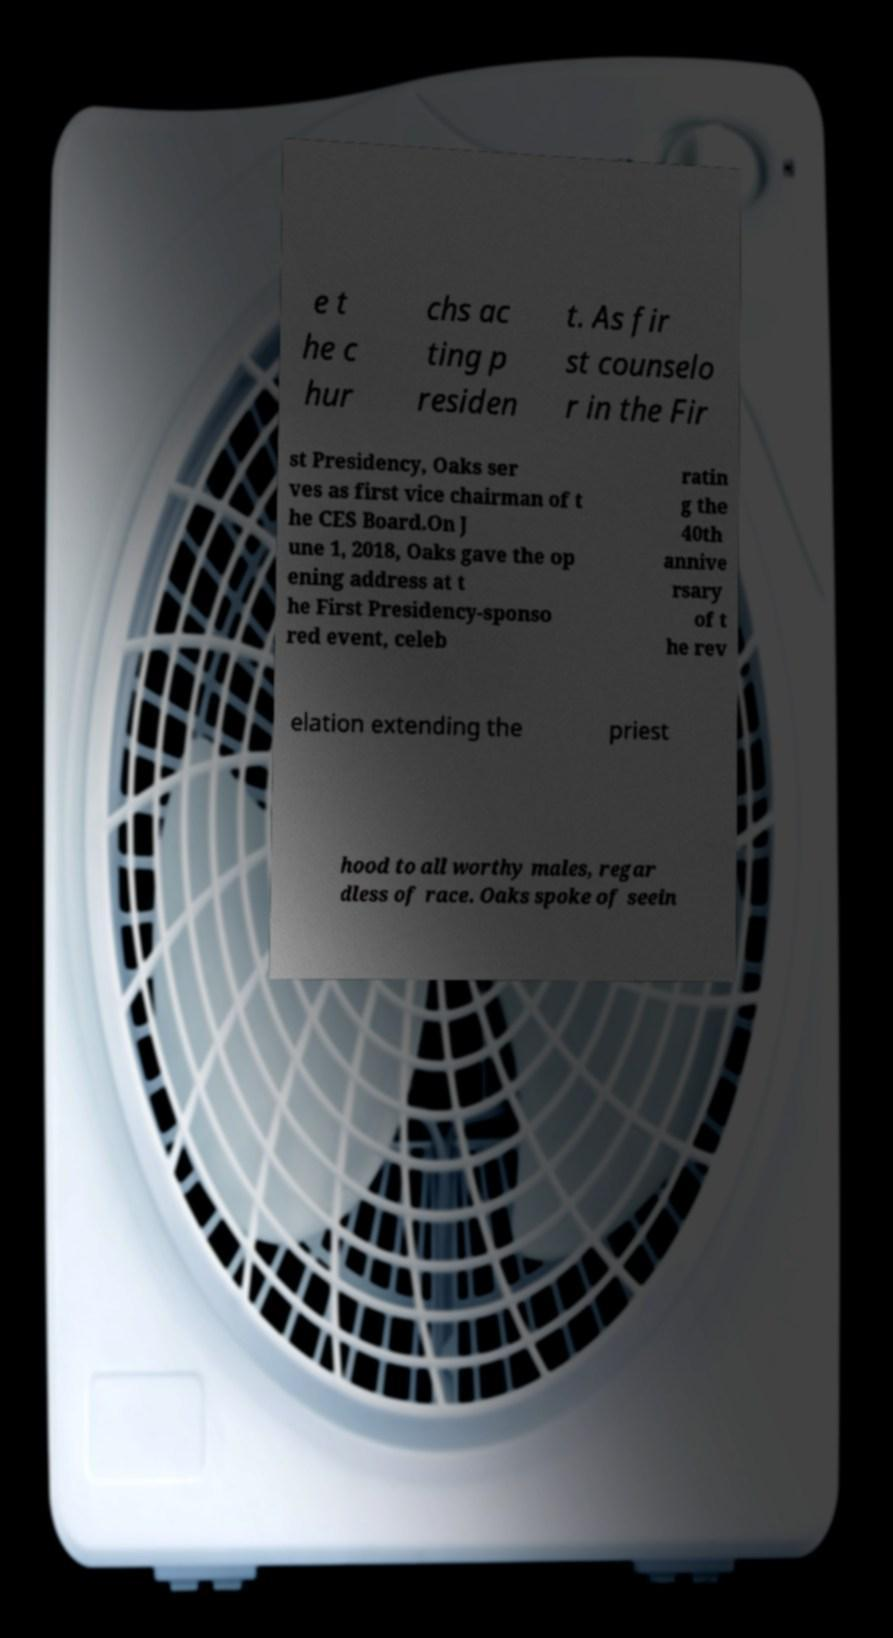Please read and relay the text visible in this image. What does it say? e t he c hur chs ac ting p residen t. As fir st counselo r in the Fir st Presidency, Oaks ser ves as first vice chairman of t he CES Board.On J une 1, 2018, Oaks gave the op ening address at t he First Presidency-sponso red event, celeb ratin g the 40th annive rsary of t he rev elation extending the priest hood to all worthy males, regar dless of race. Oaks spoke of seein 